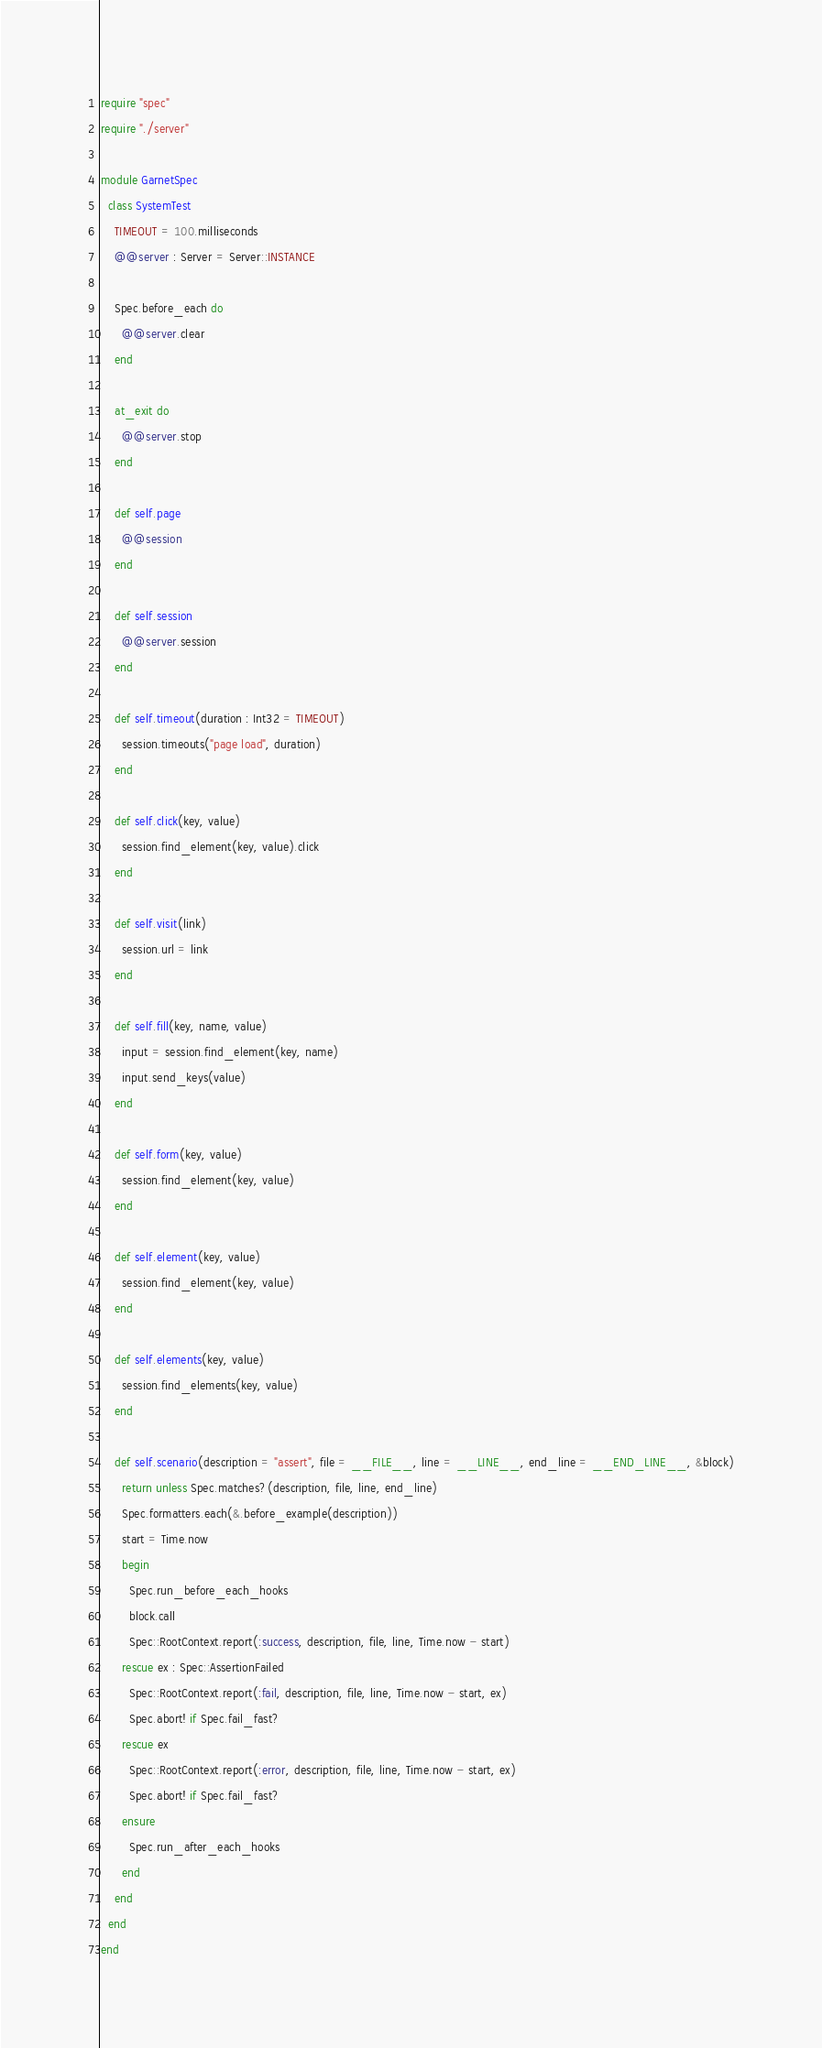Convert code to text. <code><loc_0><loc_0><loc_500><loc_500><_Crystal_>require "spec"
require "./server"

module GarnetSpec
  class SystemTest
    TIMEOUT = 100.milliseconds
    @@server : Server = Server::INSTANCE

    Spec.before_each do
      @@server.clear
    end

    at_exit do
      @@server.stop
    end

    def self.page
      @@session
    end

    def self.session
      @@server.session
    end

    def self.timeout(duration : Int32 = TIMEOUT)
      session.timeouts("page load", duration)
    end

    def self.click(key, value)
      session.find_element(key, value).click
    end

    def self.visit(link)
      session.url = link
    end

    def self.fill(key, name, value)
      input = session.find_element(key, name)
      input.send_keys(value)
    end

    def self.form(key, value)
      session.find_element(key, value)
    end

    def self.element(key, value)
      session.find_element(key, value)
    end
    
    def self.elements(key, value)
      session.find_elements(key, value)
    end

    def self.scenario(description = "assert", file = __FILE__, line = __LINE__, end_line = __END_LINE__, &block)
      return unless Spec.matches?(description, file, line, end_line)
      Spec.formatters.each(&.before_example(description))
      start = Time.now
      begin
        Spec.run_before_each_hooks
        block.call
        Spec::RootContext.report(:success, description, file, line, Time.now - start)
      rescue ex : Spec::AssertionFailed
        Spec::RootContext.report(:fail, description, file, line, Time.now - start, ex)
        Spec.abort! if Spec.fail_fast?
      rescue ex
        Spec::RootContext.report(:error, description, file, line, Time.now - start, ex)
        Spec.abort! if Spec.fail_fast?
      ensure
        Spec.run_after_each_hooks
      end
    end
  end
end
</code> 